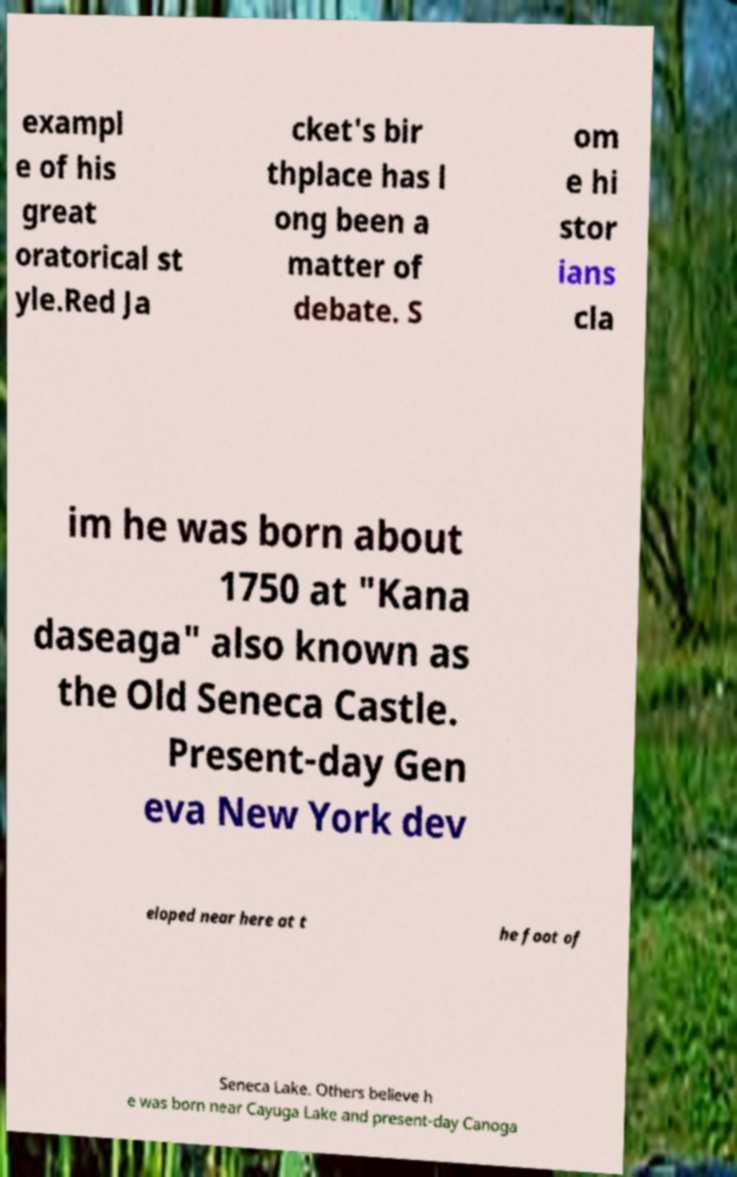Could you extract and type out the text from this image? exampl e of his great oratorical st yle.Red Ja cket's bir thplace has l ong been a matter of debate. S om e hi stor ians cla im he was born about 1750 at "Kana daseaga" also known as the Old Seneca Castle. Present-day Gen eva New York dev eloped near here at t he foot of Seneca Lake. Others believe h e was born near Cayuga Lake and present-day Canoga 